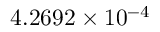Convert formula to latex. <formula><loc_0><loc_0><loc_500><loc_500>4 . 2 6 9 2 \times 1 0 ^ { - 4 }</formula> 